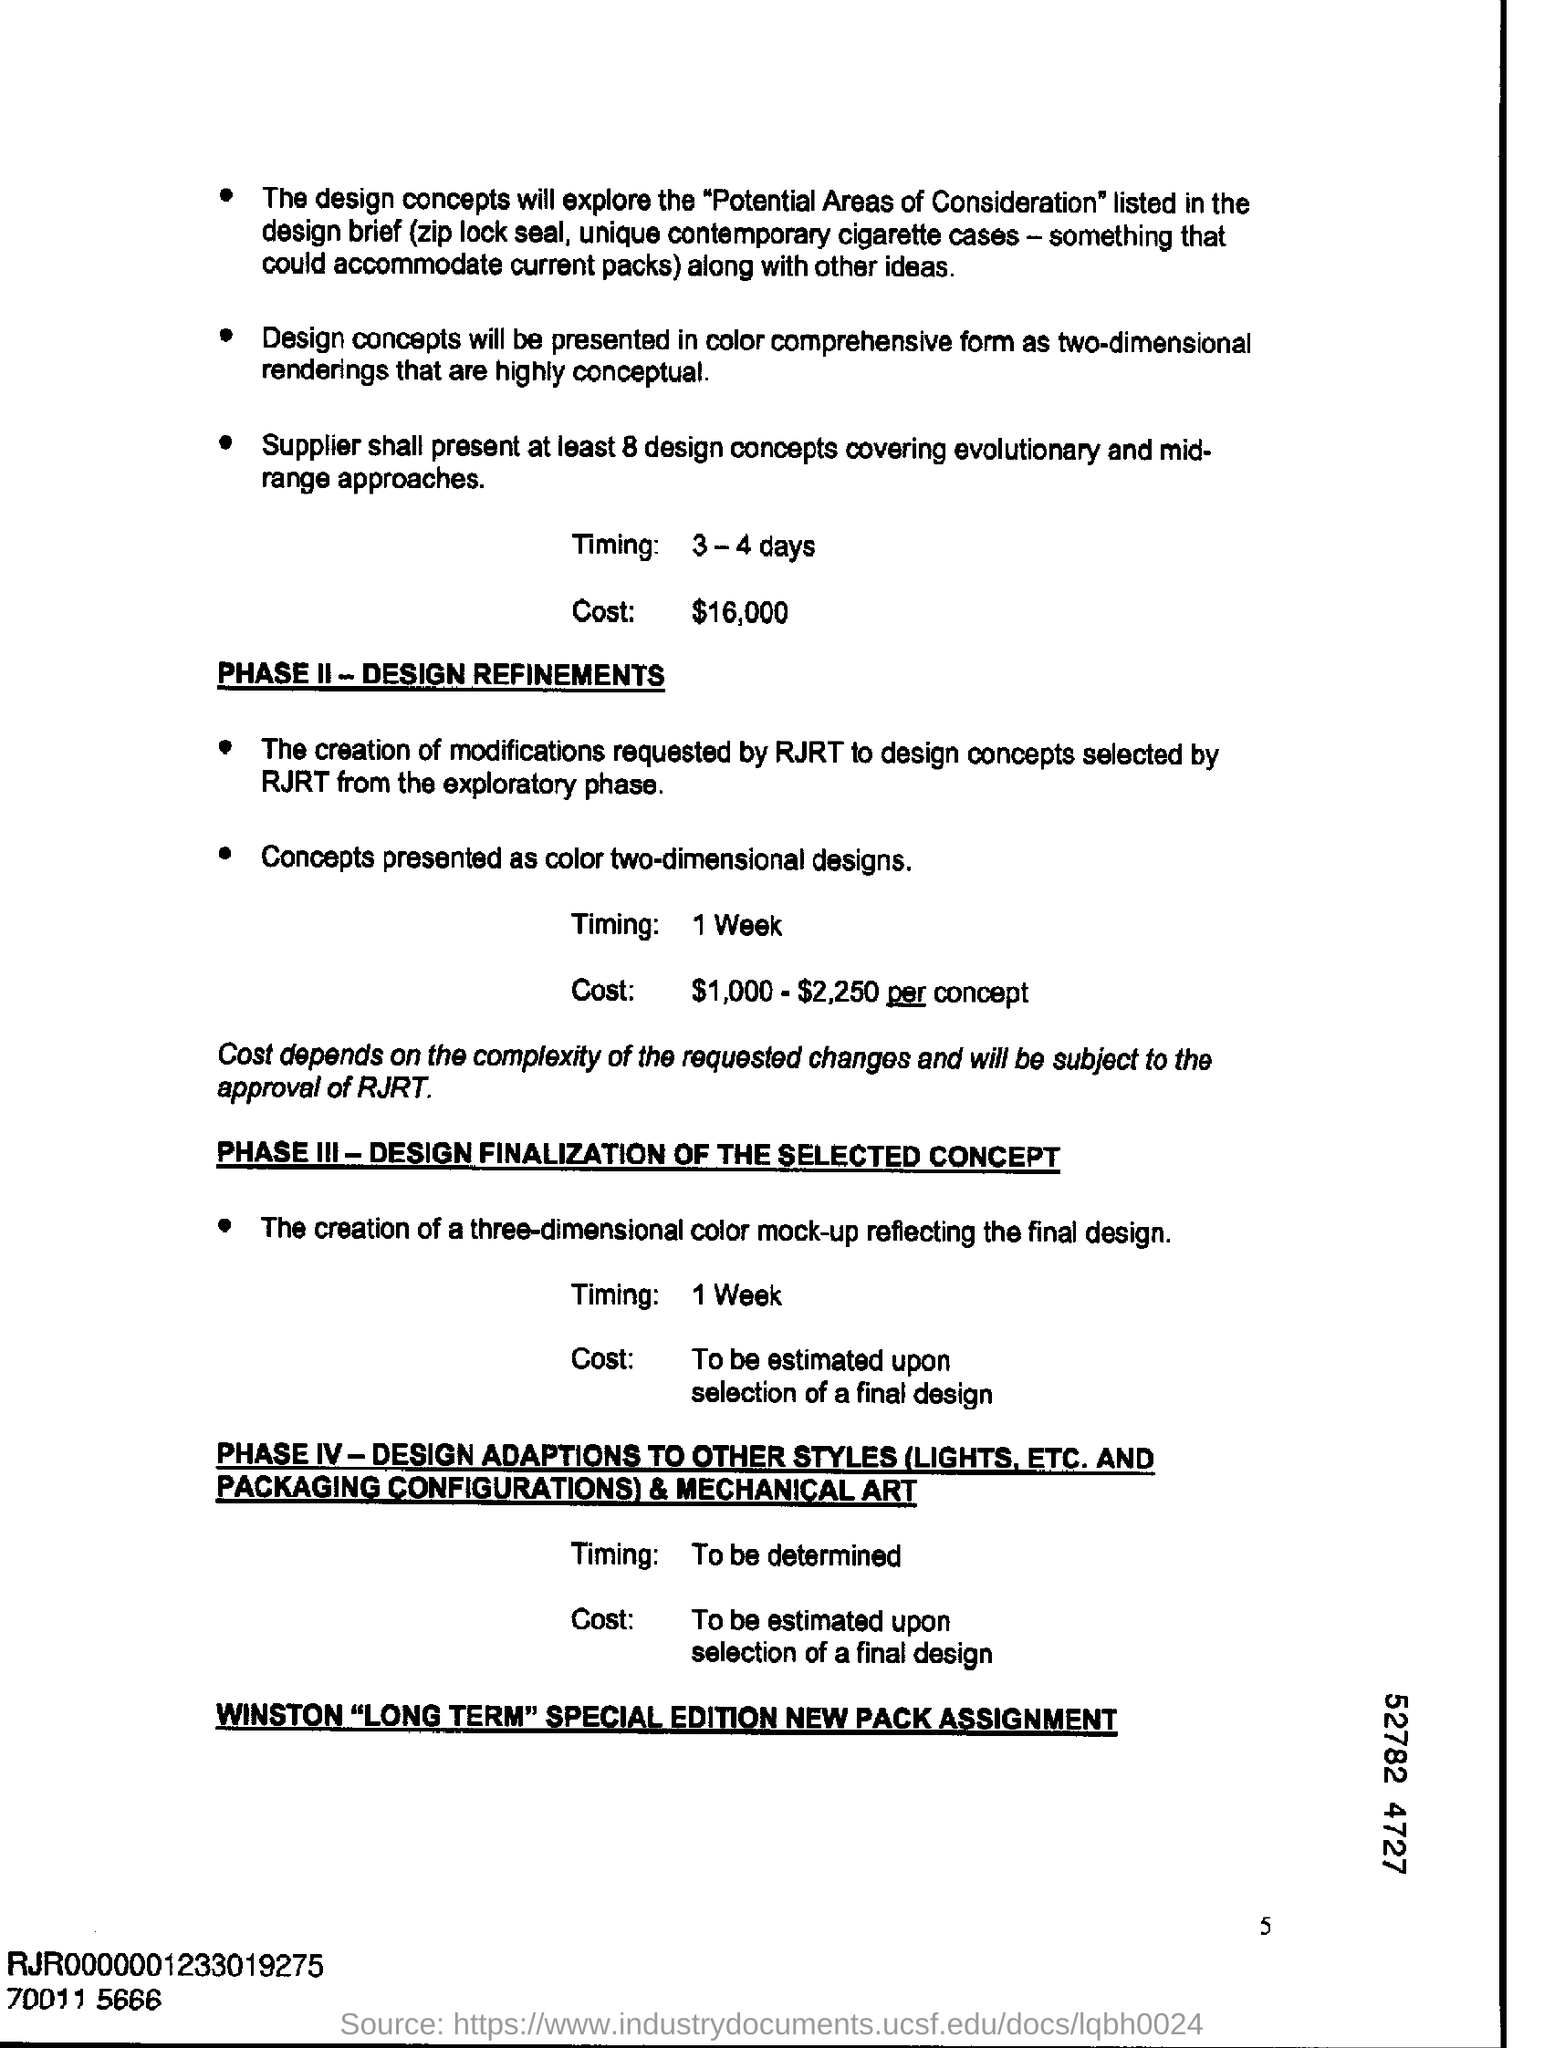Outline some significant characteristics in this image. The cost for Phase 2 ranges from $1,000 to $2,250 per concept. The cost mentioned is $16,000. The timing for phase 2 is 1 week. The timing for phase 3 is 1 week. The timing for this process is expected to take 3-4 days. 